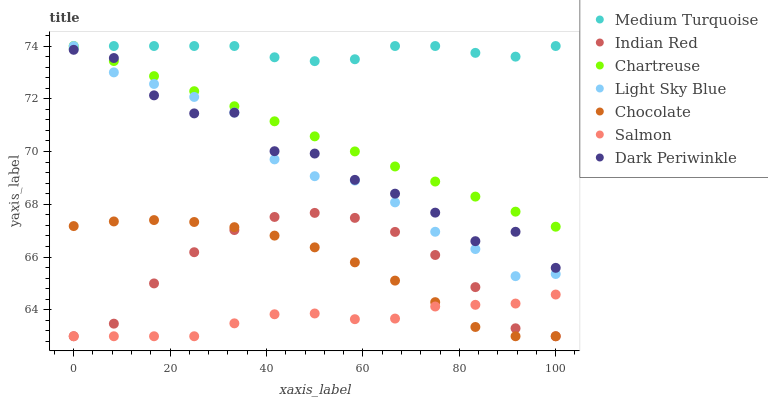Does Salmon have the minimum area under the curve?
Answer yes or no. Yes. Does Medium Turquoise have the maximum area under the curve?
Answer yes or no. Yes. Does Chocolate have the minimum area under the curve?
Answer yes or no. No. Does Chocolate have the maximum area under the curve?
Answer yes or no. No. Is Chartreuse the smoothest?
Answer yes or no. Yes. Is Dark Periwinkle the roughest?
Answer yes or no. Yes. Is Salmon the smoothest?
Answer yes or no. No. Is Salmon the roughest?
Answer yes or no. No. Does Salmon have the lowest value?
Answer yes or no. Yes. Does Chartreuse have the lowest value?
Answer yes or no. No. Does Light Sky Blue have the highest value?
Answer yes or no. Yes. Does Chocolate have the highest value?
Answer yes or no. No. Is Chocolate less than Chartreuse?
Answer yes or no. Yes. Is Medium Turquoise greater than Indian Red?
Answer yes or no. Yes. Does Light Sky Blue intersect Medium Turquoise?
Answer yes or no. Yes. Is Light Sky Blue less than Medium Turquoise?
Answer yes or no. No. Is Light Sky Blue greater than Medium Turquoise?
Answer yes or no. No. Does Chocolate intersect Chartreuse?
Answer yes or no. No. 